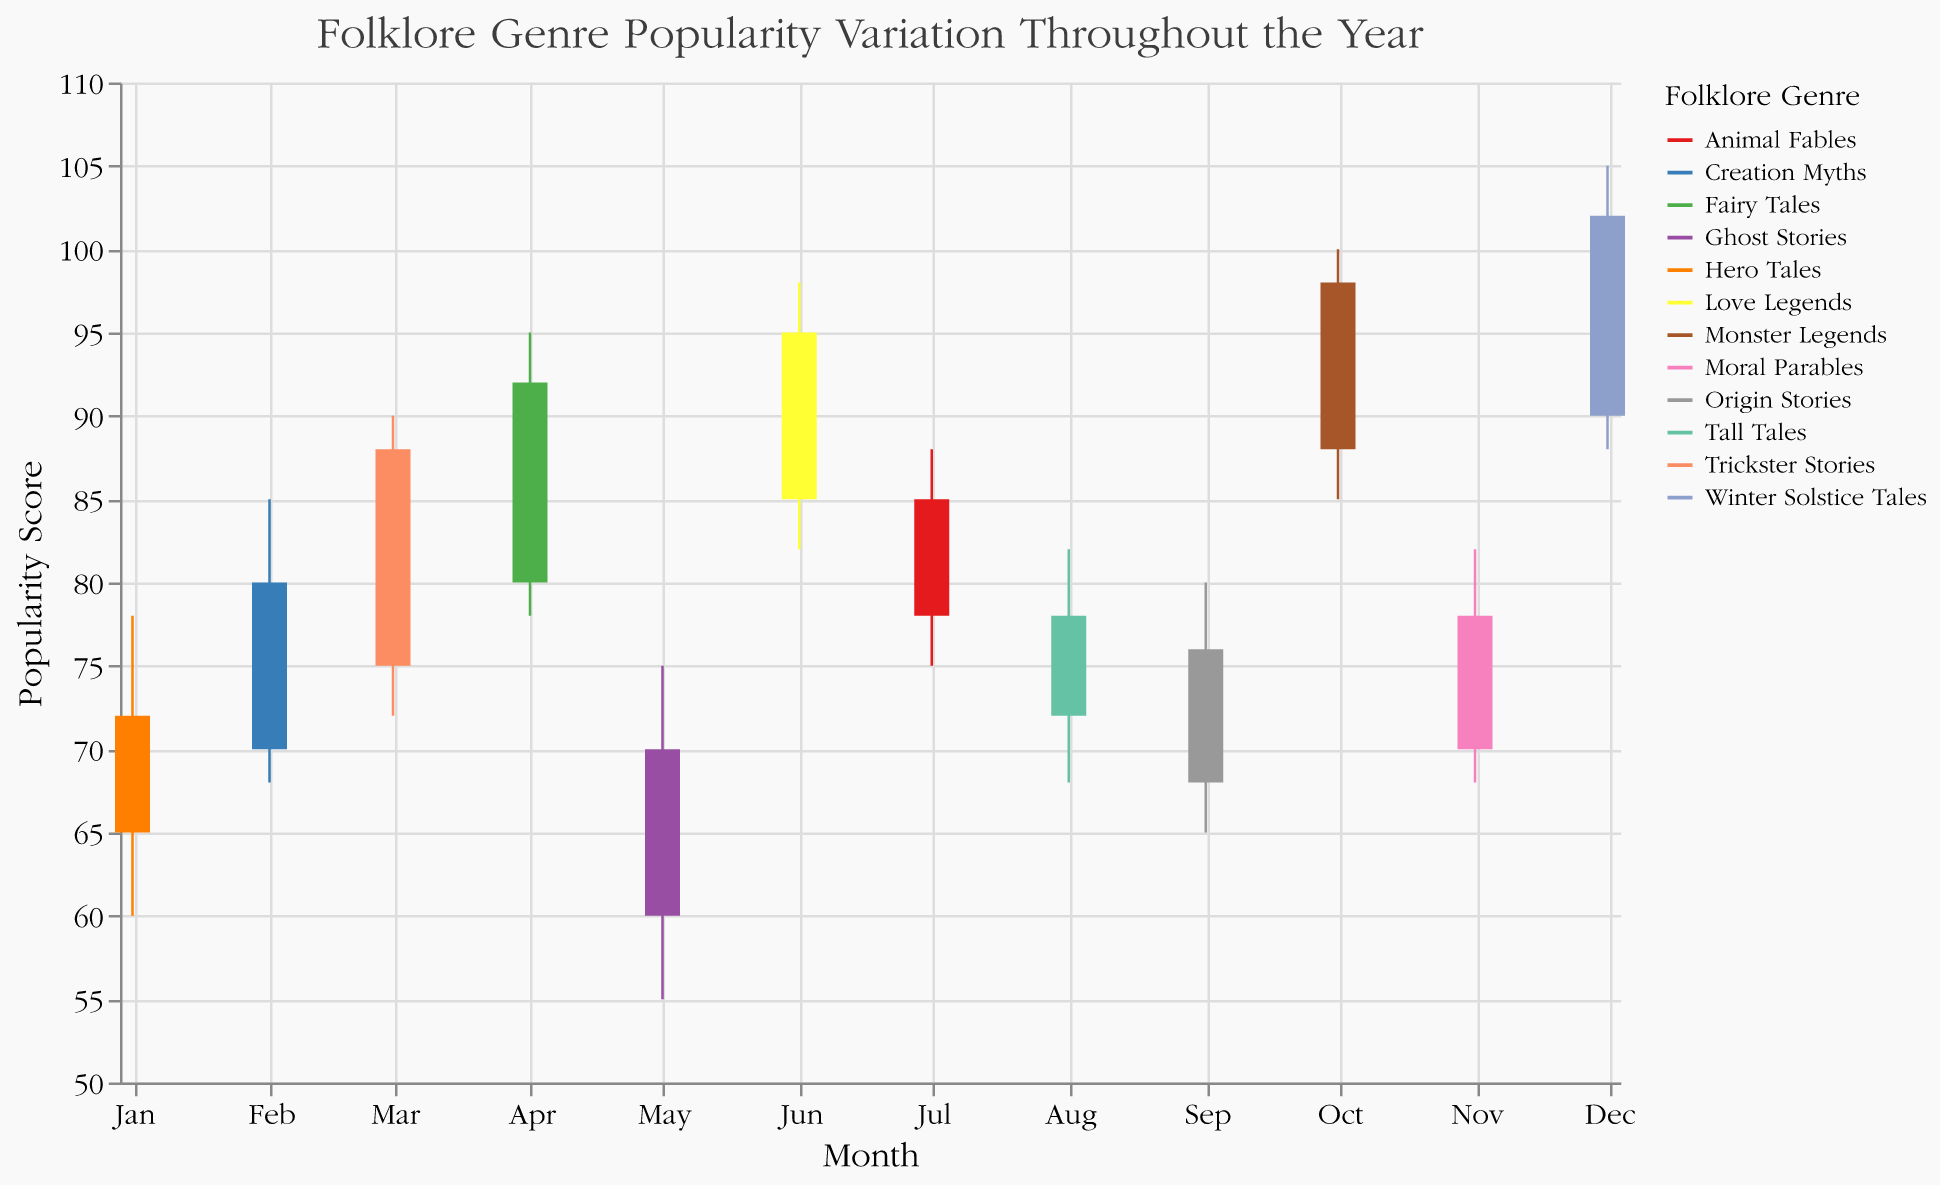What is the highest popularity score recorded for any genre throughout the year? The highest popularity score can be identified by looking at the "High" value points for each genre. The highest point in the chart is 105 for "Winter Solstice Tales" in December.
Answer: 105 Which genre experienced the lowest popularity score in the month of May? To find the genre with the lowest score in May, we need to observe the "Low" value for May. "Ghost Stories" have the lowest "Low" value of 55 for May.
Answer: Ghost Stories Which folklore genre showed the highest increase in popularity from its opening to closing scores in October? For October, compare the difference between the "Open" and "Close" values for the genre "Monster Legends". The increase is 98 - 88 = 10. Other genres aren't linked to October.
Answer: Monster Legends Which genre saw the largest range between its highest and lowest scores in any given month? To determine the largest range, calculate High - Low for each genre: Hero Tales (18), Creation Myths (17), Trickster Stories (18), Fairy Tales (17), Ghost Stories (20), Love Legends (16), Animal Fables (13), Tall Tales (14), Origin Stories (15), Monster Legends (15), Moral Parables (14), Winter Solstice Tales (17). The largest range is 20 for "Ghost Stories"
Answer: Ghost Stories What trend do we observe for folklore popularity in December? Look at the "Winter Solstice Tales" entry for December: Open (90), Close (102), High (105), Low (88). There is an upward trend in popularity indicated by the closing score being higher than the opening score, and the high score reaching 105.
Answer: Upward trend Which genre had the smallest difference between its highest and lowest scores in the given months? Compare the difference High - Low for all genres and identify the smallest. We find: "Animal Fables" differences are smallest with High (88) - Low (75) = 13.
Answer: Animal Fables Is there any genre that showed a decline in popularity from opening to closing scores in July? Check the "Open" and "Close" values for July data: Animal Fables (Open 78, Close 85). The close value is greater than the open value, indicating no decline.
Answer: No In which month did "Fairy Tales" reach their peak popularity, and what was the score? Identify "Fairy Tales" data for April. The "High" value for April is 95, which is the peak score for this genre.
Answer: April, 95 Which folklore genre had its highest popularity score in January, and what was it? Look at the "High" value for January data: "Hero Tales" with the "High" value of 78.
Answer: Hero Tales, 78 